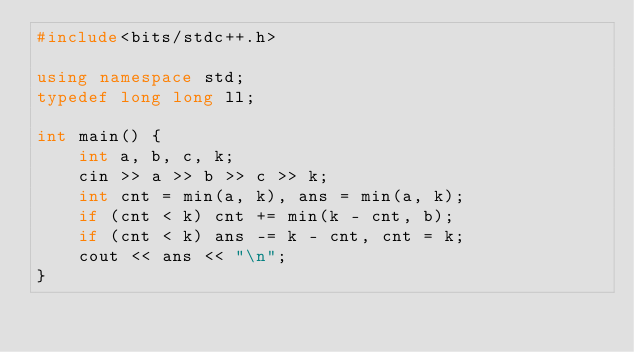<code> <loc_0><loc_0><loc_500><loc_500><_C++_>#include<bits/stdc++.h>

using namespace std;
typedef long long ll;

int main() {
    int a, b, c, k;
    cin >> a >> b >> c >> k;
    int cnt = min(a, k), ans = min(a, k);
    if (cnt < k) cnt += min(k - cnt, b);
    if (cnt < k) ans -= k - cnt, cnt = k;
    cout << ans << "\n";
}
</code> 